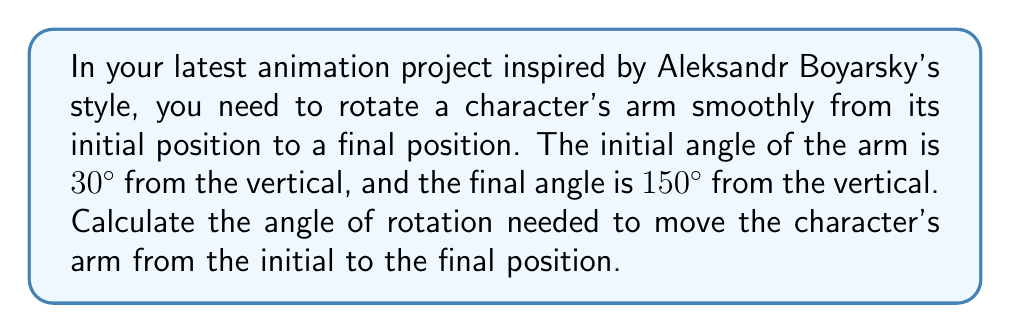What is the answer to this math problem? Let's approach this step-by-step:

1) First, let's visualize the problem:
   [asy]
   import geometry;
   
   size(200);
   
   draw((-1,0)--(1,0), arrow=Arrow);
   draw((0,-1)--(0,1), arrow=Arrow);
   
   draw((0,0)--(cos(radians(30)),sin(radians(30))), arrow=Arrow, blue);
   draw((0,0)--(cos(radians(150)),sin(radians(150))), arrow=Arrow, red);
   
   label("30°", (0.3,0.3), blue);
   label("150°", (-0.3,0.3), red);
   label("Initial", (0.7,0.5), blue);
   label("Final", (-0.7,0.5), red);
   [/asy]

2) The angle of rotation is the difference between the final and initial angles:

   $$\text{Rotation Angle} = \text{Final Angle} - \text{Initial Angle}$$

3) Substituting the given values:

   $$\text{Rotation Angle} = 150° - 30°$$

4) Calculating the difference:

   $$\text{Rotation Angle} = 120°$$

5) Note: The direction of rotation is counterclockwise, as the angle increases from 30° to 150°.
Answer: 120° 